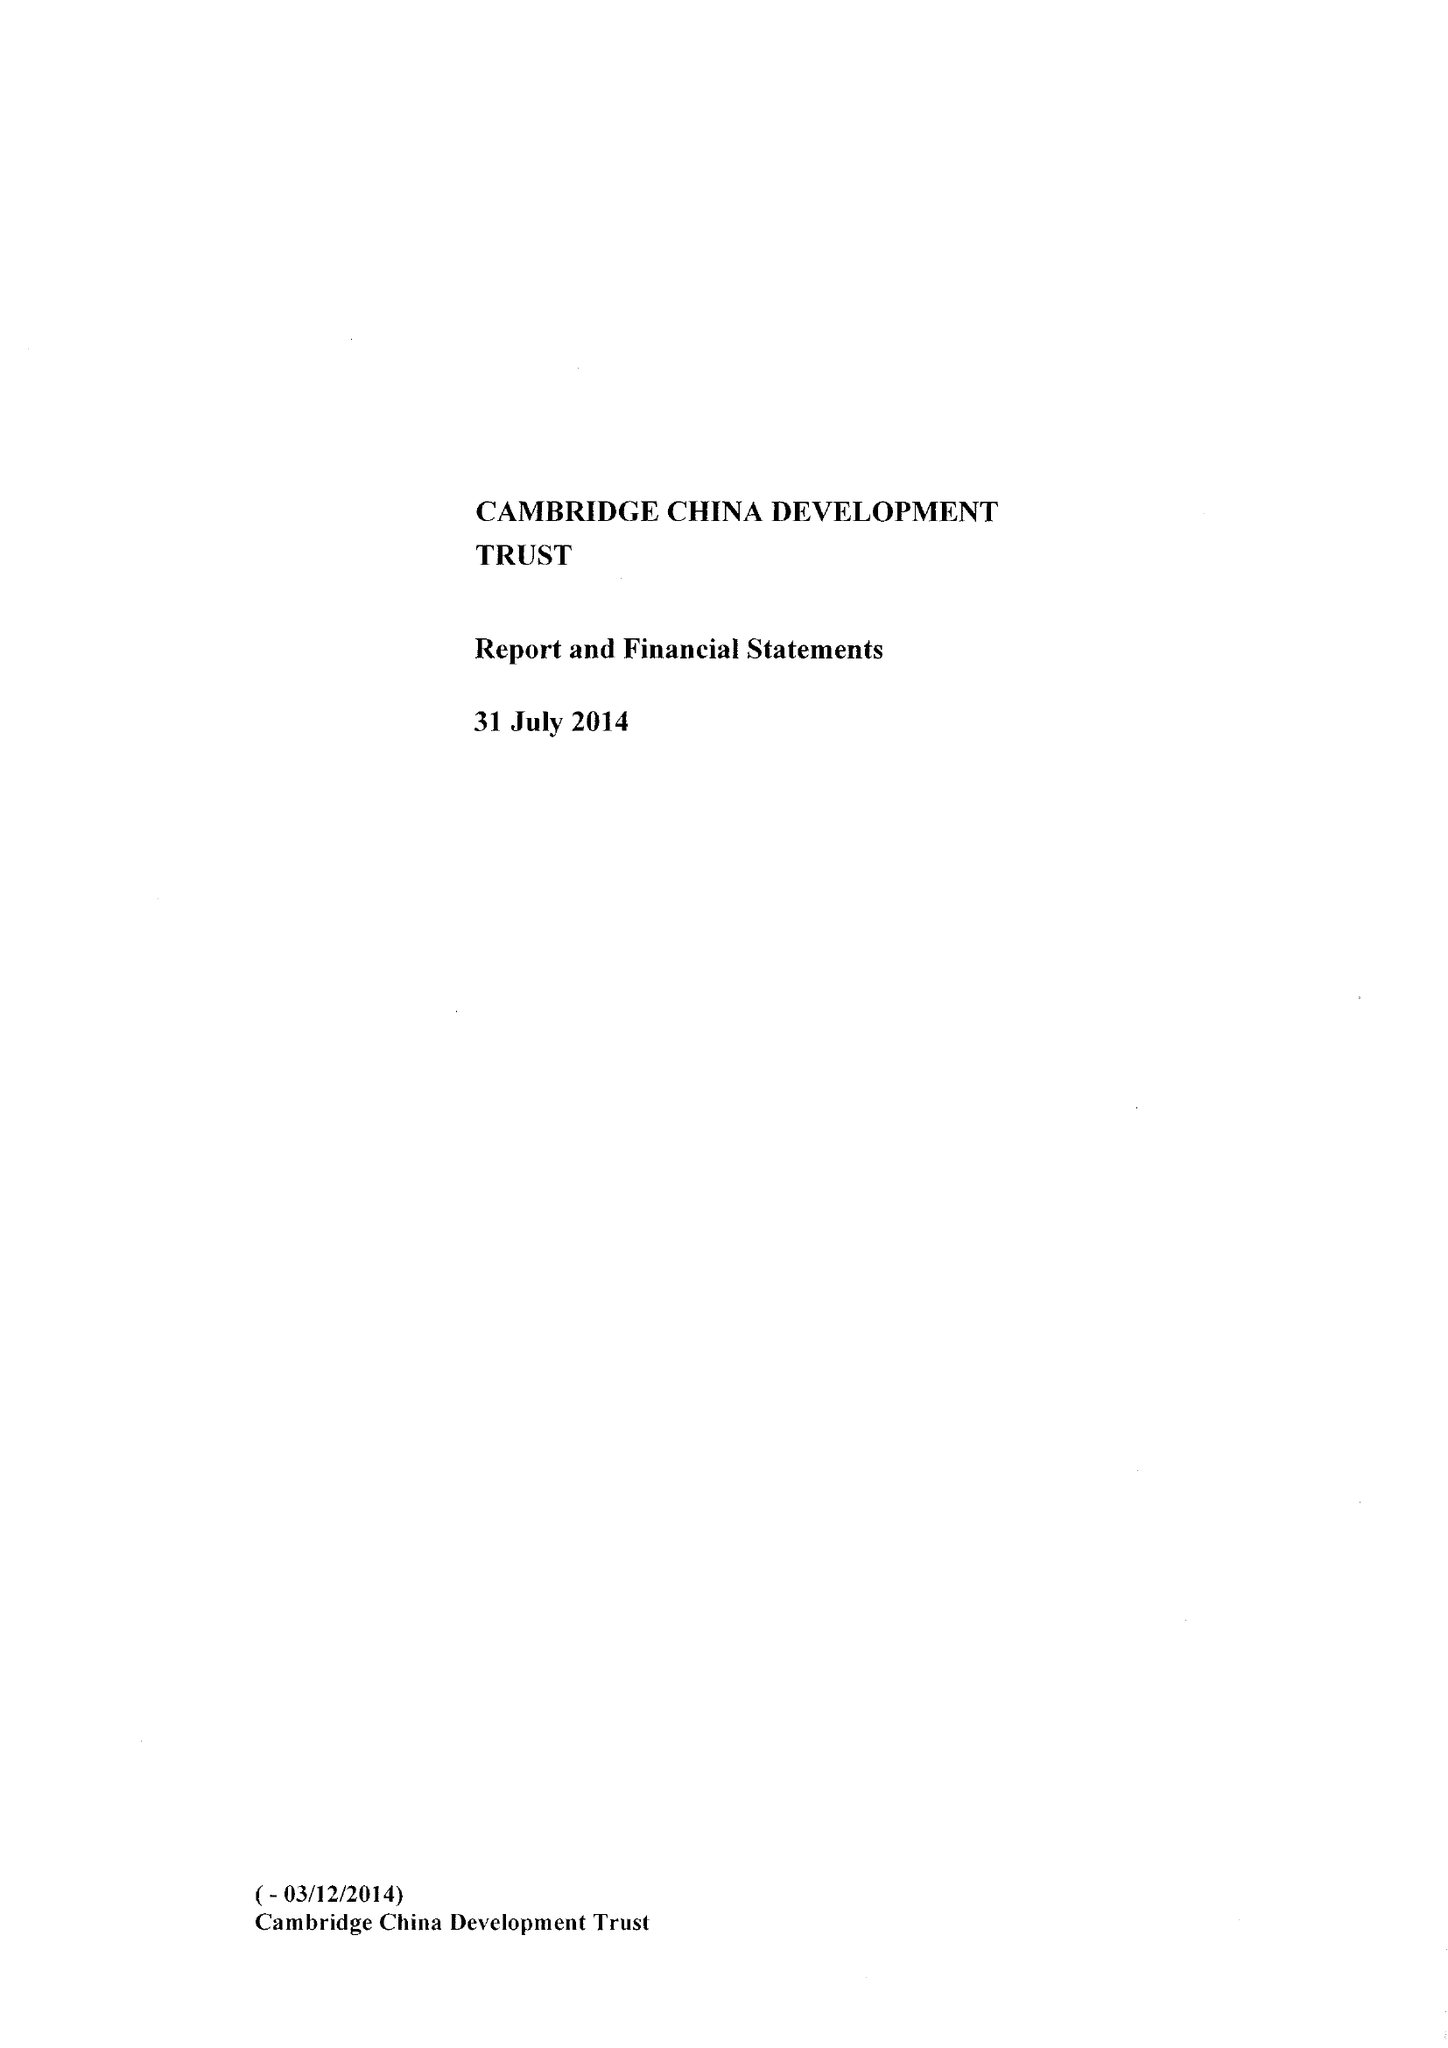What is the value for the address__post_town?
Answer the question using a single word or phrase. CAMBRIDGE 